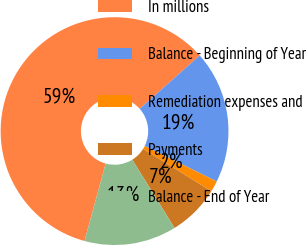<chart> <loc_0><loc_0><loc_500><loc_500><pie_chart><fcel>In millions<fcel>Balance - Beginning of Year<fcel>Remediation expenses and<fcel>Payments<fcel>Balance - End of Year<nl><fcel>59.19%<fcel>18.85%<fcel>1.56%<fcel>7.32%<fcel>13.08%<nl></chart> 